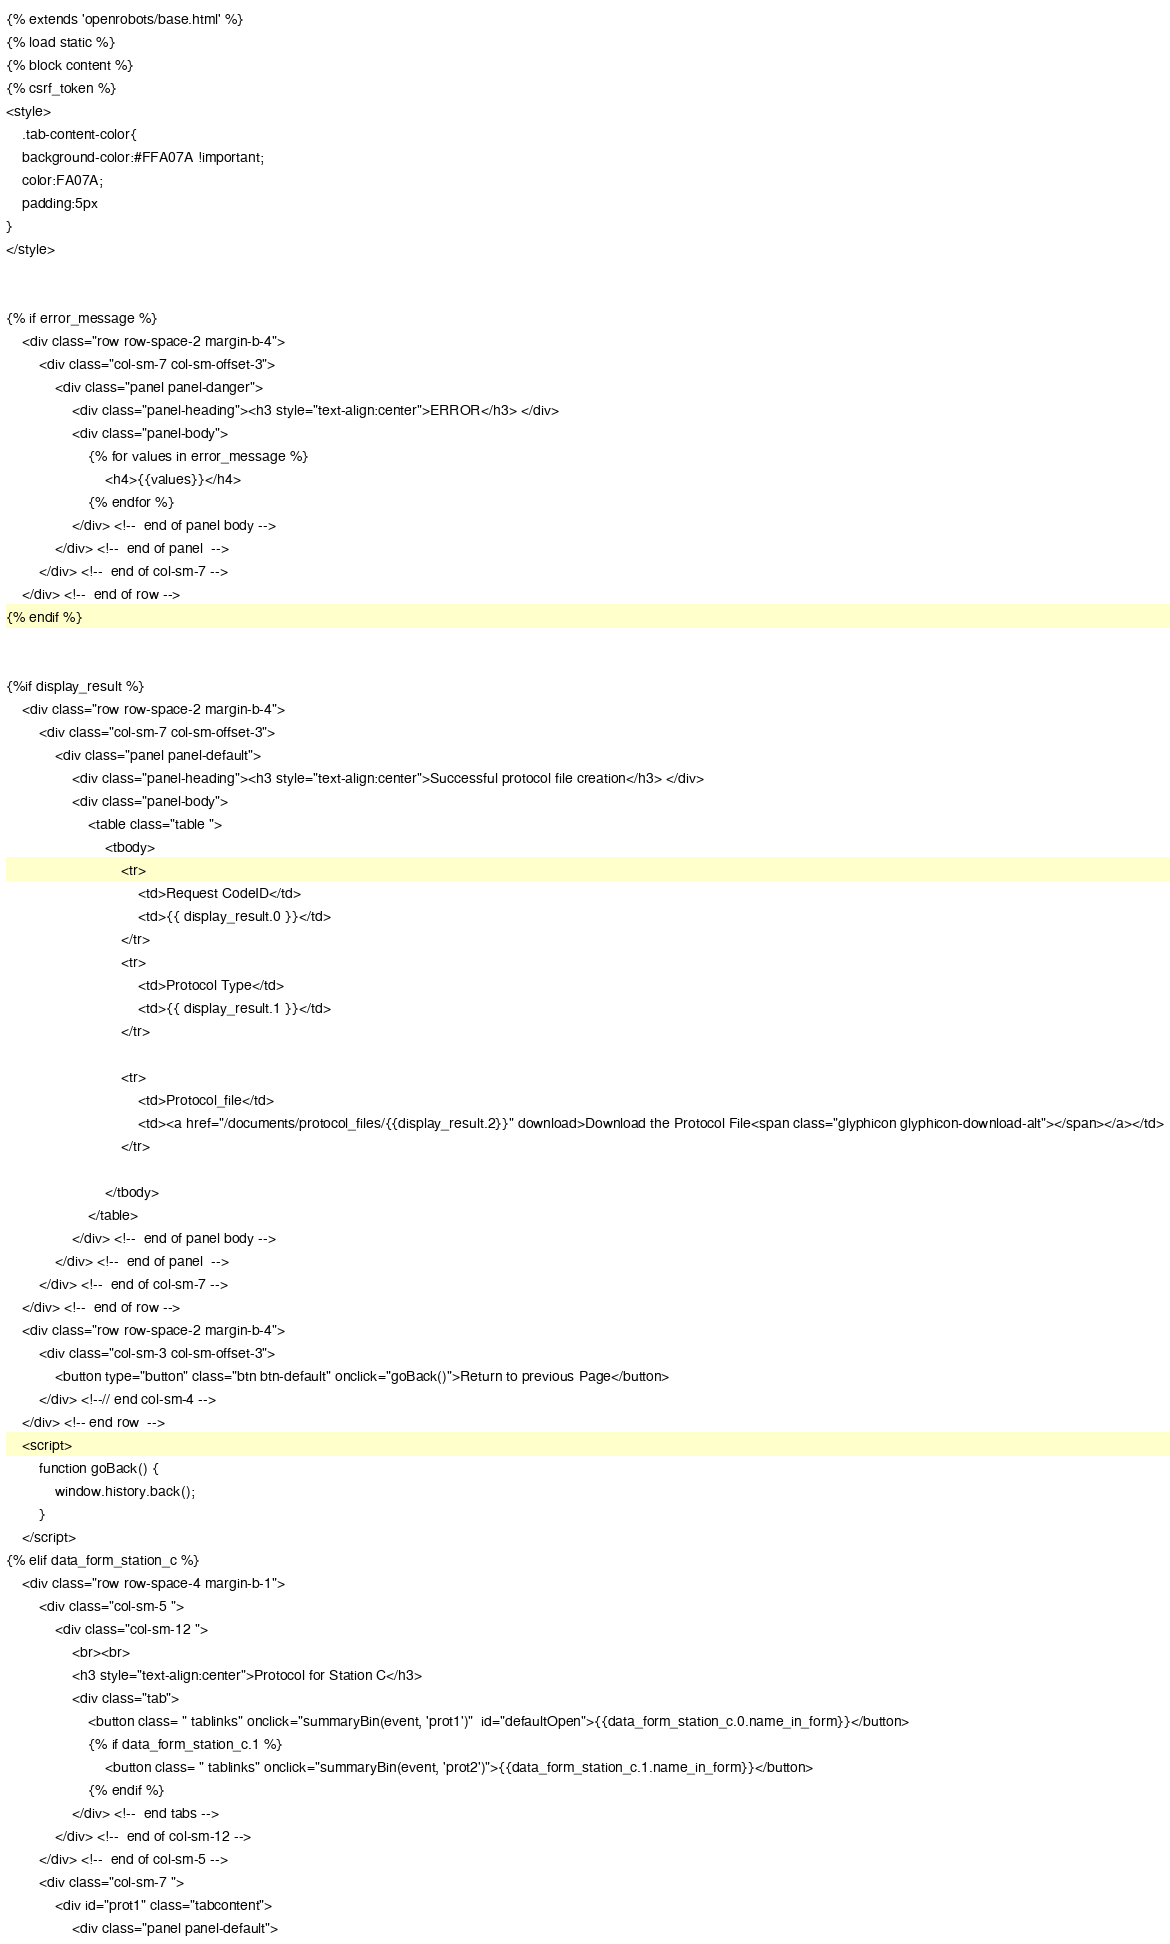<code> <loc_0><loc_0><loc_500><loc_500><_HTML_>{% extends 'openrobots/base.html' %}
{% load static %}
{% block content %}
{% csrf_token %}
<style>
    .tab-content-color{
    background-color:#FFA07A !important;
    color:FA07A;
    padding:5px
}
</style>


{% if error_message %}
    <div class="row row-space-2 margin-b-4">
        <div class="col-sm-7 col-sm-offset-3">
            <div class="panel panel-danger">
                <div class="panel-heading"><h3 style="text-align:center">ERROR</h3> </div>
                <div class="panel-body">
                    {% for values in error_message %}
                        <h4>{{values}}</h4>
                    {% endfor %}
                </div> <!--  end of panel body -->
            </div> <!--  end of panel  -->
        </div> <!--  end of col-sm-7 -->
    </div> <!--  end of row -->
{% endif %}


{%if display_result %}
    <div class="row row-space-2 margin-b-4">
        <div class="col-sm-7 col-sm-offset-3">
            <div class="panel panel-default">
                <div class="panel-heading"><h3 style="text-align:center">Successful protocol file creation</h3> </div>
                <div class="panel-body">
                    <table class="table ">
    					<tbody>
    						<tr>
    							<td>Request CodeID</td>
                                <td>{{ display_result.0 }}</td>
                            </tr>
                            <tr>
    							<td>Protocol Type</td>
                                <td>{{ display_result.1 }}</td>
                            </tr>

                            <tr>
    							<td>Protocol_file</td>
                                <td><a href="/documents/protocol_files/{{display_result.2}}" download>Download the Protocol File<span class="glyphicon glyphicon-download-alt"></span></a></td>
                            </tr>

    					</tbody>
    				</table>
                </div> <!--  end of panel body -->
            </div> <!--  end of panel  -->
        </div> <!--  end of col-sm-7 -->
    </div> <!--  end of row -->
    <div class="row row-space-2 margin-b-4">
        <div class="col-sm-3 col-sm-offset-3">
            <button type="button" class="btn btn-default" onclick="goBack()">Return to previous Page</button>
        </div> <!--// end col-sm-4 -->
    </div> <!-- end row  -->
    <script>
        function goBack() {
            window.history.back();
        }
    </script>
{% elif data_form_station_c %}
    <div class="row row-space-4 margin-b-1">
        <div class="col-sm-5 ">
            <div class="col-sm-12 ">
                <br><br>
                <h3 style="text-align:center">Protocol for Station C</h3>
                <div class="tab">
                    <button class= " tablinks" onclick="summaryBin(event, 'prot1')"  id="defaultOpen">{{data_form_station_c.0.name_in_form}}</button>
                    {% if data_form_station_c.1 %}
                        <button class= " tablinks" onclick="summaryBin(event, 'prot2')">{{data_form_station_c.1.name_in_form}}</button>
                    {% endif %}
                </div> <!--  end tabs -->
            </div> <!--  end of col-sm-12 -->
        </div> <!--  end of col-sm-5 -->
        <div class="col-sm-7 ">
            <div id="prot1" class="tabcontent">
                <div class="panel panel-default"></code> 